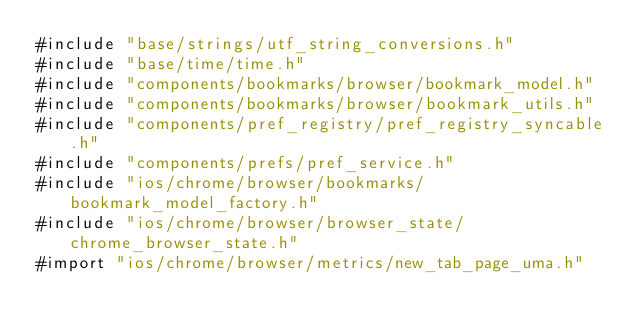Convert code to text. <code><loc_0><loc_0><loc_500><loc_500><_ObjectiveC_>#include "base/strings/utf_string_conversions.h"
#include "base/time/time.h"
#include "components/bookmarks/browser/bookmark_model.h"
#include "components/bookmarks/browser/bookmark_utils.h"
#include "components/pref_registry/pref_registry_syncable.h"
#include "components/prefs/pref_service.h"
#include "ios/chrome/browser/bookmarks/bookmark_model_factory.h"
#include "ios/chrome/browser/browser_state/chrome_browser_state.h"
#import "ios/chrome/browser/metrics/new_tab_page_uma.h"</code> 